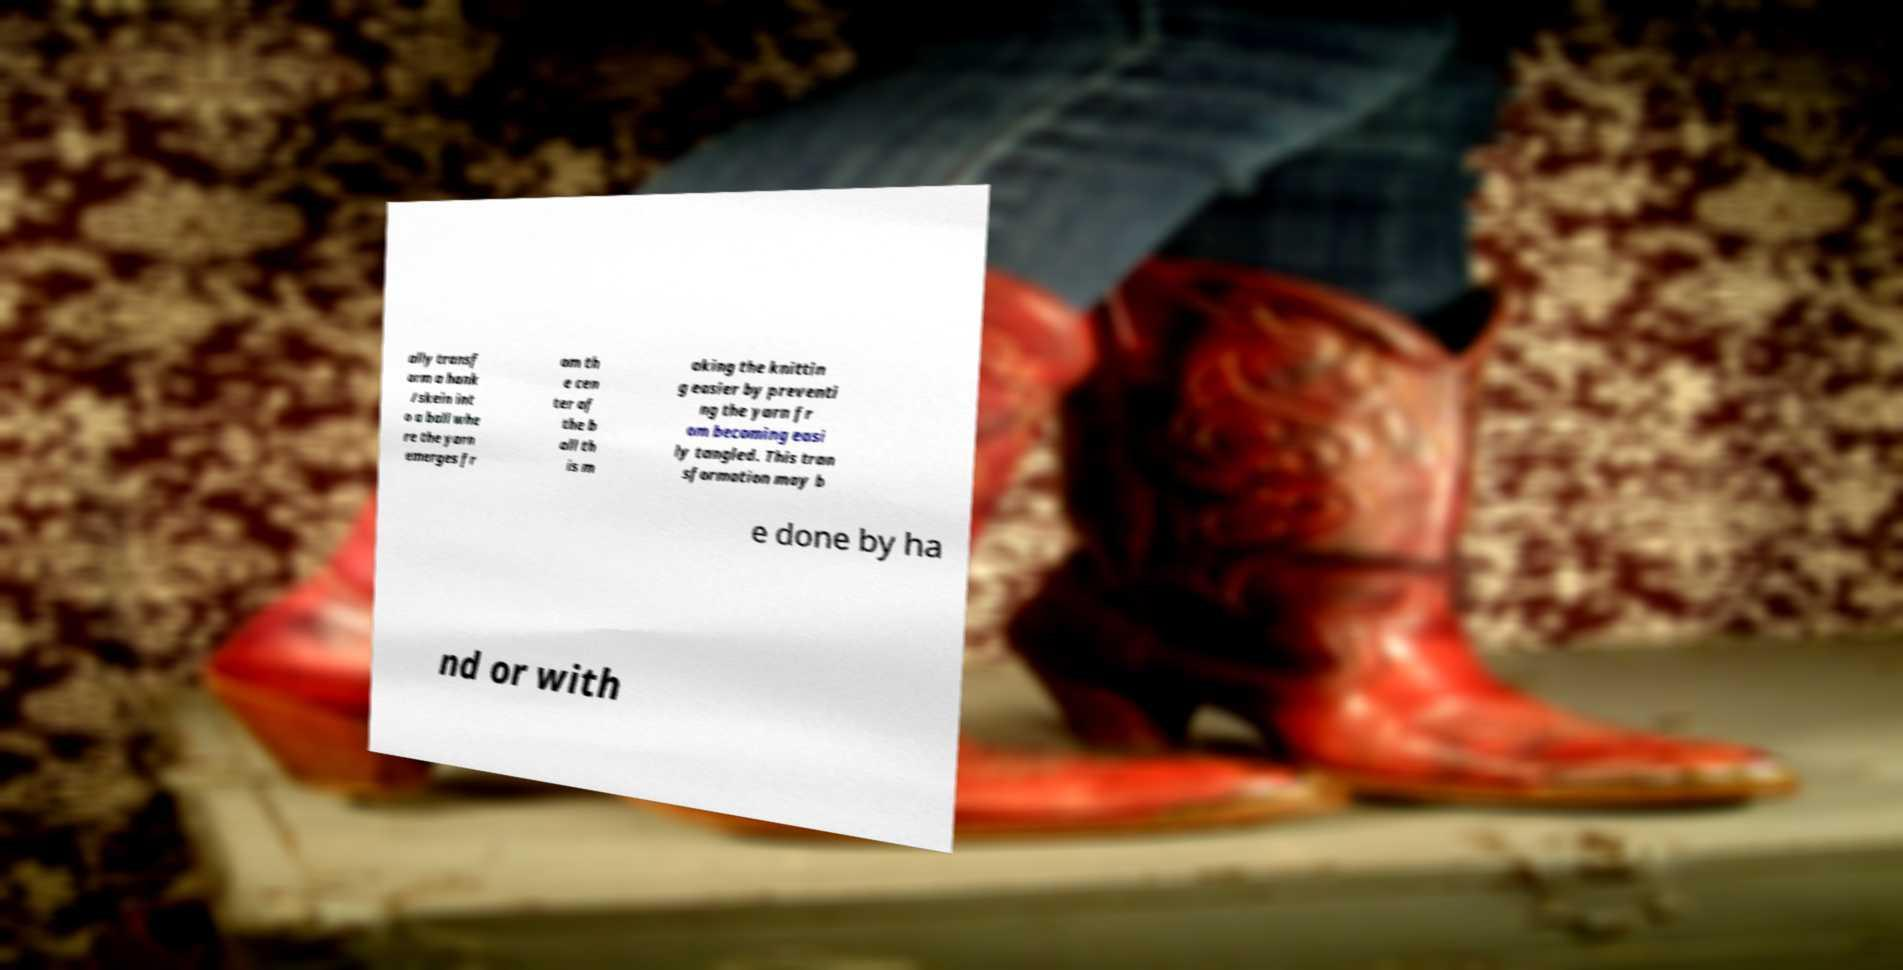Can you read and provide the text displayed in the image?This photo seems to have some interesting text. Can you extract and type it out for me? ally transf orm a hank /skein int o a ball whe re the yarn emerges fr om th e cen ter of the b all th is m aking the knittin g easier by preventi ng the yarn fr om becoming easi ly tangled. This tran sformation may b e done by ha nd or with 